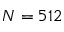Convert formula to latex. <formula><loc_0><loc_0><loc_500><loc_500>N = 5 1 2</formula> 